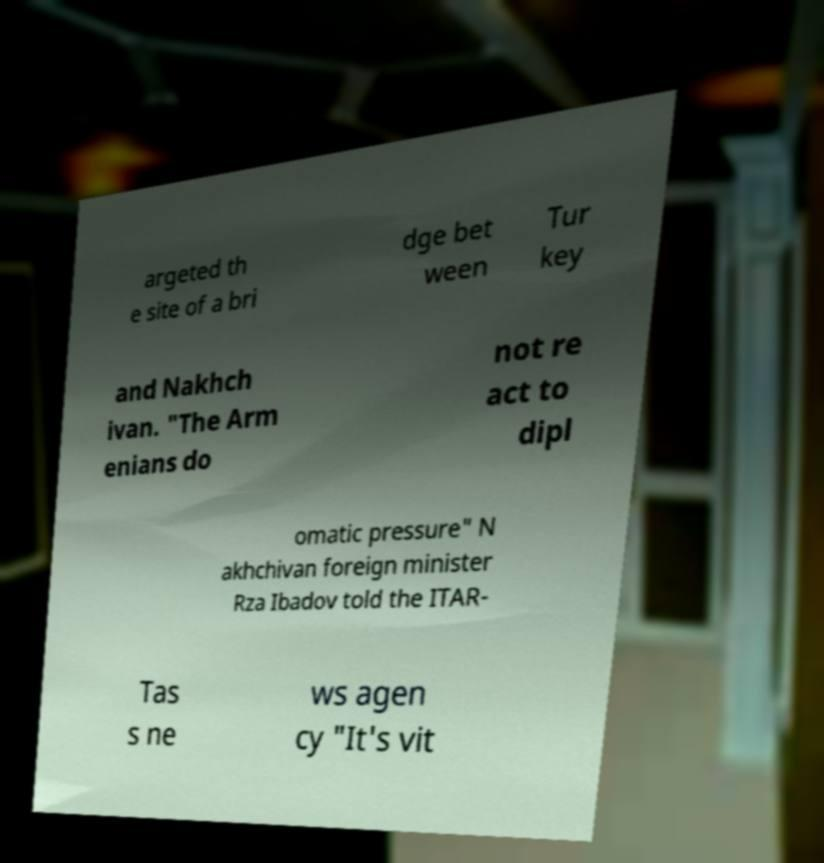I need the written content from this picture converted into text. Can you do that? argeted th e site of a bri dge bet ween Tur key and Nakhch ivan. "The Arm enians do not re act to dipl omatic pressure" N akhchivan foreign minister Rza Ibadov told the ITAR- Tas s ne ws agen cy "It's vit 